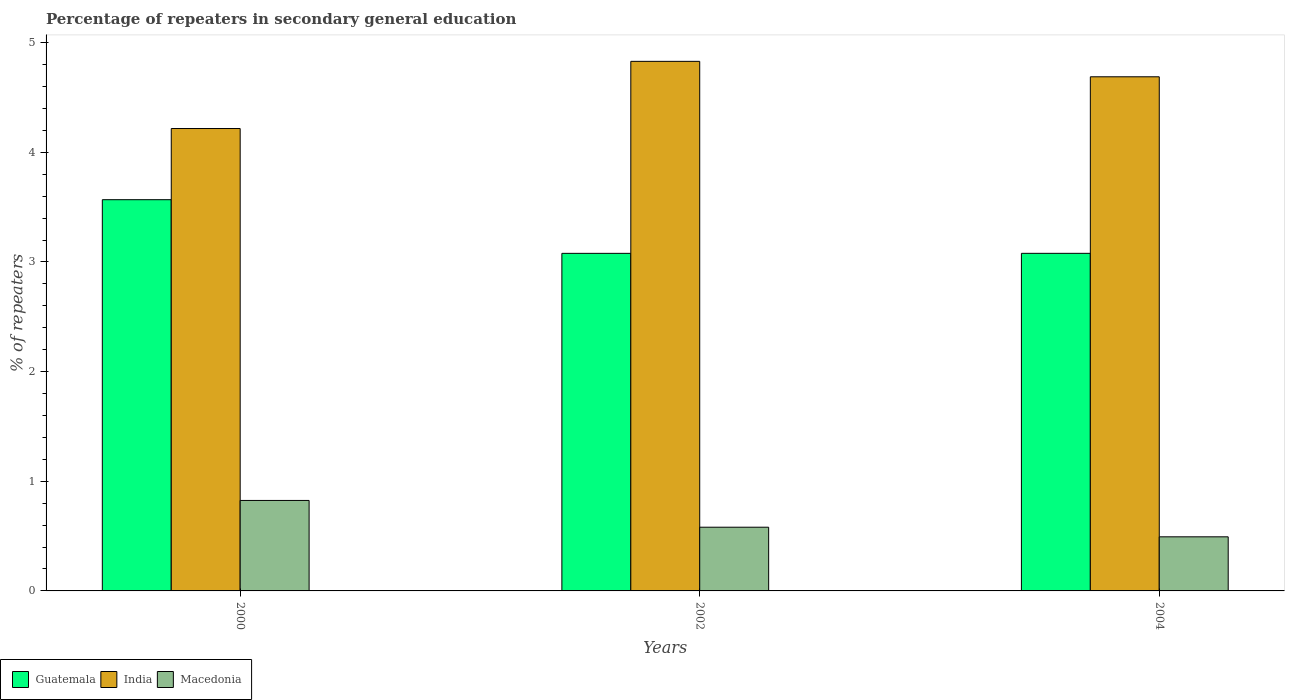How many different coloured bars are there?
Your answer should be very brief. 3. How many groups of bars are there?
Your response must be concise. 3. Are the number of bars per tick equal to the number of legend labels?
Your response must be concise. Yes. Are the number of bars on each tick of the X-axis equal?
Offer a terse response. Yes. How many bars are there on the 1st tick from the right?
Keep it short and to the point. 3. What is the percentage of repeaters in secondary general education in Guatemala in 2000?
Ensure brevity in your answer.  3.57. Across all years, what is the maximum percentage of repeaters in secondary general education in India?
Make the answer very short. 4.83. Across all years, what is the minimum percentage of repeaters in secondary general education in Macedonia?
Give a very brief answer. 0.49. In which year was the percentage of repeaters in secondary general education in Macedonia minimum?
Offer a terse response. 2004. What is the total percentage of repeaters in secondary general education in Guatemala in the graph?
Make the answer very short. 9.72. What is the difference between the percentage of repeaters in secondary general education in India in 2000 and that in 2002?
Provide a succinct answer. -0.61. What is the difference between the percentage of repeaters in secondary general education in Macedonia in 2000 and the percentage of repeaters in secondary general education in Guatemala in 2004?
Keep it short and to the point. -2.25. What is the average percentage of repeaters in secondary general education in India per year?
Your response must be concise. 4.58. In the year 2002, what is the difference between the percentage of repeaters in secondary general education in India and percentage of repeaters in secondary general education in Macedonia?
Offer a very short reply. 4.25. What is the ratio of the percentage of repeaters in secondary general education in Guatemala in 2000 to that in 2002?
Ensure brevity in your answer.  1.16. Is the percentage of repeaters in secondary general education in Macedonia in 2000 less than that in 2002?
Ensure brevity in your answer.  No. What is the difference between the highest and the second highest percentage of repeaters in secondary general education in India?
Your answer should be very brief. 0.14. What is the difference between the highest and the lowest percentage of repeaters in secondary general education in Guatemala?
Provide a short and direct response. 0.49. Is the sum of the percentage of repeaters in secondary general education in Guatemala in 2000 and 2002 greater than the maximum percentage of repeaters in secondary general education in Macedonia across all years?
Your answer should be compact. Yes. What does the 2nd bar from the right in 2004 represents?
Your response must be concise. India. How many bars are there?
Your answer should be very brief. 9. How many years are there in the graph?
Provide a succinct answer. 3. What is the difference between two consecutive major ticks on the Y-axis?
Offer a very short reply. 1. Does the graph contain any zero values?
Ensure brevity in your answer.  No. Does the graph contain grids?
Offer a terse response. No. How many legend labels are there?
Provide a short and direct response. 3. How are the legend labels stacked?
Make the answer very short. Horizontal. What is the title of the graph?
Make the answer very short. Percentage of repeaters in secondary general education. Does "Egypt, Arab Rep." appear as one of the legend labels in the graph?
Provide a succinct answer. No. What is the label or title of the Y-axis?
Offer a terse response. % of repeaters. What is the % of repeaters in Guatemala in 2000?
Your response must be concise. 3.57. What is the % of repeaters in India in 2000?
Offer a terse response. 4.22. What is the % of repeaters of Macedonia in 2000?
Offer a terse response. 0.83. What is the % of repeaters of Guatemala in 2002?
Provide a succinct answer. 3.08. What is the % of repeaters in India in 2002?
Offer a terse response. 4.83. What is the % of repeaters of Macedonia in 2002?
Your answer should be compact. 0.58. What is the % of repeaters in Guatemala in 2004?
Give a very brief answer. 3.08. What is the % of repeaters in India in 2004?
Provide a short and direct response. 4.69. What is the % of repeaters in Macedonia in 2004?
Provide a short and direct response. 0.49. Across all years, what is the maximum % of repeaters of Guatemala?
Your answer should be compact. 3.57. Across all years, what is the maximum % of repeaters in India?
Keep it short and to the point. 4.83. Across all years, what is the maximum % of repeaters in Macedonia?
Offer a very short reply. 0.83. Across all years, what is the minimum % of repeaters in Guatemala?
Offer a very short reply. 3.08. Across all years, what is the minimum % of repeaters in India?
Provide a short and direct response. 4.22. Across all years, what is the minimum % of repeaters in Macedonia?
Make the answer very short. 0.49. What is the total % of repeaters of Guatemala in the graph?
Keep it short and to the point. 9.72. What is the total % of repeaters in India in the graph?
Give a very brief answer. 13.73. What is the total % of repeaters of Macedonia in the graph?
Your answer should be very brief. 1.9. What is the difference between the % of repeaters in Guatemala in 2000 and that in 2002?
Offer a very short reply. 0.49. What is the difference between the % of repeaters of India in 2000 and that in 2002?
Provide a succinct answer. -0.61. What is the difference between the % of repeaters of Macedonia in 2000 and that in 2002?
Provide a short and direct response. 0.24. What is the difference between the % of repeaters of Guatemala in 2000 and that in 2004?
Provide a succinct answer. 0.49. What is the difference between the % of repeaters of India in 2000 and that in 2004?
Provide a short and direct response. -0.47. What is the difference between the % of repeaters of Macedonia in 2000 and that in 2004?
Give a very brief answer. 0.33. What is the difference between the % of repeaters in Guatemala in 2002 and that in 2004?
Your answer should be very brief. -0. What is the difference between the % of repeaters of India in 2002 and that in 2004?
Your answer should be very brief. 0.14. What is the difference between the % of repeaters of Macedonia in 2002 and that in 2004?
Make the answer very short. 0.09. What is the difference between the % of repeaters in Guatemala in 2000 and the % of repeaters in India in 2002?
Provide a short and direct response. -1.26. What is the difference between the % of repeaters in Guatemala in 2000 and the % of repeaters in Macedonia in 2002?
Ensure brevity in your answer.  2.99. What is the difference between the % of repeaters in India in 2000 and the % of repeaters in Macedonia in 2002?
Ensure brevity in your answer.  3.64. What is the difference between the % of repeaters in Guatemala in 2000 and the % of repeaters in India in 2004?
Your response must be concise. -1.12. What is the difference between the % of repeaters of Guatemala in 2000 and the % of repeaters of Macedonia in 2004?
Offer a very short reply. 3.07. What is the difference between the % of repeaters in India in 2000 and the % of repeaters in Macedonia in 2004?
Make the answer very short. 3.72. What is the difference between the % of repeaters of Guatemala in 2002 and the % of repeaters of India in 2004?
Your answer should be very brief. -1.61. What is the difference between the % of repeaters in Guatemala in 2002 and the % of repeaters in Macedonia in 2004?
Your response must be concise. 2.59. What is the difference between the % of repeaters in India in 2002 and the % of repeaters in Macedonia in 2004?
Ensure brevity in your answer.  4.34. What is the average % of repeaters in Guatemala per year?
Provide a succinct answer. 3.24. What is the average % of repeaters in India per year?
Ensure brevity in your answer.  4.58. What is the average % of repeaters in Macedonia per year?
Provide a short and direct response. 0.63. In the year 2000, what is the difference between the % of repeaters in Guatemala and % of repeaters in India?
Provide a short and direct response. -0.65. In the year 2000, what is the difference between the % of repeaters in Guatemala and % of repeaters in Macedonia?
Keep it short and to the point. 2.74. In the year 2000, what is the difference between the % of repeaters in India and % of repeaters in Macedonia?
Make the answer very short. 3.39. In the year 2002, what is the difference between the % of repeaters in Guatemala and % of repeaters in India?
Ensure brevity in your answer.  -1.75. In the year 2002, what is the difference between the % of repeaters in Guatemala and % of repeaters in Macedonia?
Make the answer very short. 2.5. In the year 2002, what is the difference between the % of repeaters of India and % of repeaters of Macedonia?
Your response must be concise. 4.25. In the year 2004, what is the difference between the % of repeaters of Guatemala and % of repeaters of India?
Provide a short and direct response. -1.61. In the year 2004, what is the difference between the % of repeaters of Guatemala and % of repeaters of Macedonia?
Your response must be concise. 2.59. In the year 2004, what is the difference between the % of repeaters of India and % of repeaters of Macedonia?
Your response must be concise. 4.2. What is the ratio of the % of repeaters in Guatemala in 2000 to that in 2002?
Ensure brevity in your answer.  1.16. What is the ratio of the % of repeaters of India in 2000 to that in 2002?
Offer a very short reply. 0.87. What is the ratio of the % of repeaters in Macedonia in 2000 to that in 2002?
Ensure brevity in your answer.  1.42. What is the ratio of the % of repeaters of Guatemala in 2000 to that in 2004?
Offer a terse response. 1.16. What is the ratio of the % of repeaters of India in 2000 to that in 2004?
Ensure brevity in your answer.  0.9. What is the ratio of the % of repeaters of Macedonia in 2000 to that in 2004?
Give a very brief answer. 1.67. What is the ratio of the % of repeaters of Guatemala in 2002 to that in 2004?
Provide a short and direct response. 1. What is the ratio of the % of repeaters of Macedonia in 2002 to that in 2004?
Keep it short and to the point. 1.18. What is the difference between the highest and the second highest % of repeaters of Guatemala?
Make the answer very short. 0.49. What is the difference between the highest and the second highest % of repeaters in India?
Offer a very short reply. 0.14. What is the difference between the highest and the second highest % of repeaters of Macedonia?
Your answer should be very brief. 0.24. What is the difference between the highest and the lowest % of repeaters of Guatemala?
Keep it short and to the point. 0.49. What is the difference between the highest and the lowest % of repeaters of India?
Your answer should be very brief. 0.61. What is the difference between the highest and the lowest % of repeaters in Macedonia?
Provide a short and direct response. 0.33. 